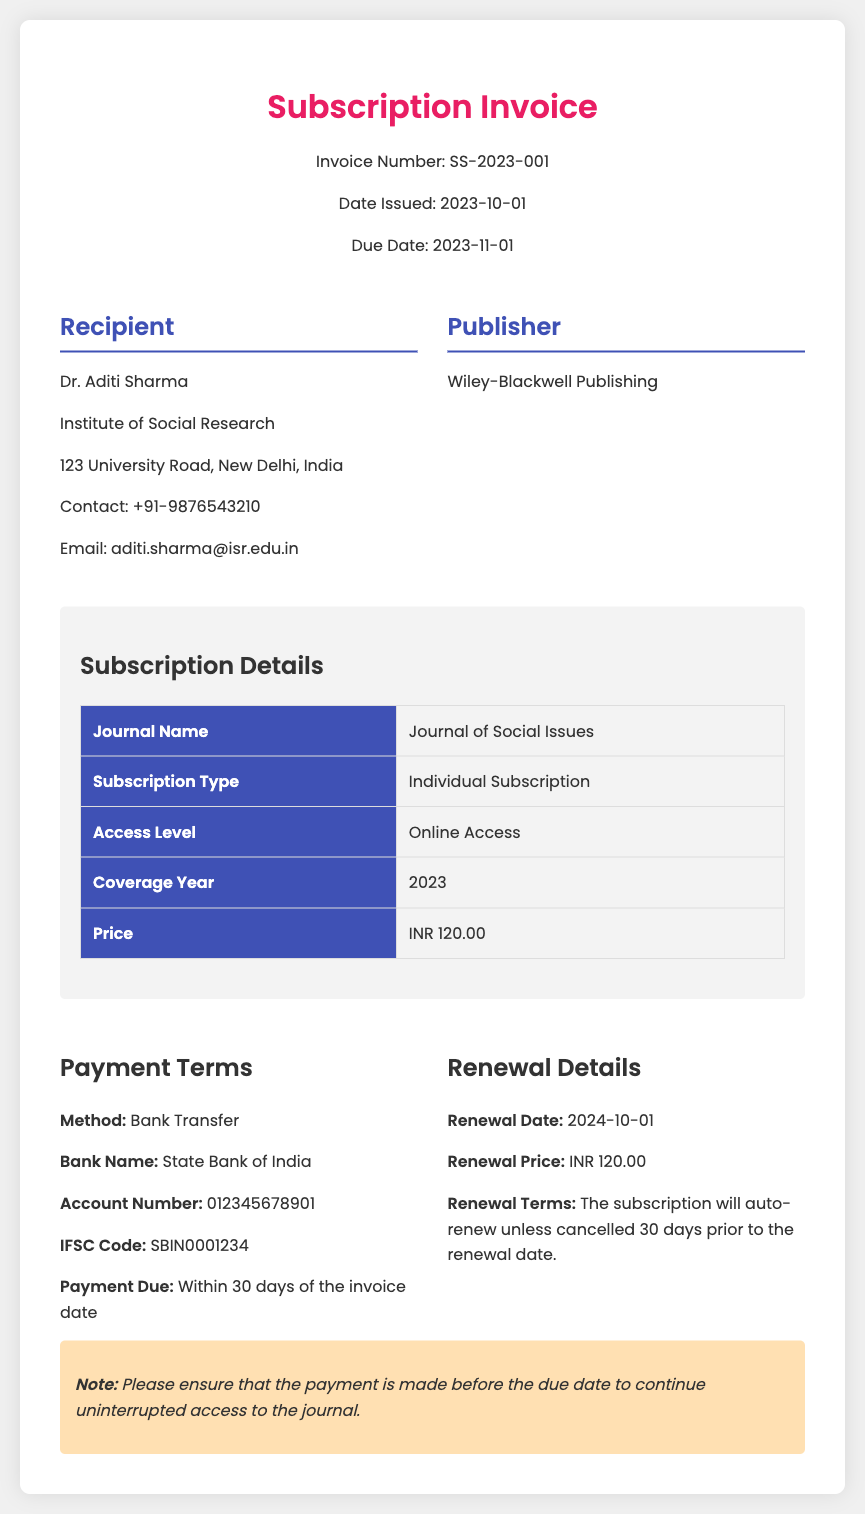What is the invoice number? The invoice number is a specific identifier for the document, listed at the top.
Answer: SS-2023-001 Who is the recipient of the invoice? The recipient is the person or organization to whom the invoice is issued, detailed in the recipient section.
Answer: Dr. Aditi Sharma What is the due date for the payment? The due date indicates when the payment should be made, clearly stated in the header.
Answer: 2023-11-01 What is the subscription type? The subscription type describes the nature of the subscription, as listed in the subscription details.
Answer: Individual Subscription What is the renewal price? The renewal price is the cost for continuing the subscription after the initial term, noted in the renewal details.
Answer: INR 120.00 What is the payment method? The payment method specifies how the payment will be made according to the payment terms section.
Answer: Bank Transfer What happens if the subscription is not cancelled 30 days prior to the renewal date? This question assesses the reasoning based on renewal terms presented in the document.
Answer: The subscription will auto-renew What is the bank name for the payment? The bank name is a crucial detail for making the payment, found in the payment terms section.
Answer: State Bank of India What is the coverage year for this subscription? The coverage year indicates the period the subscription covers, provided in the subscription details.
Answer: 2023 